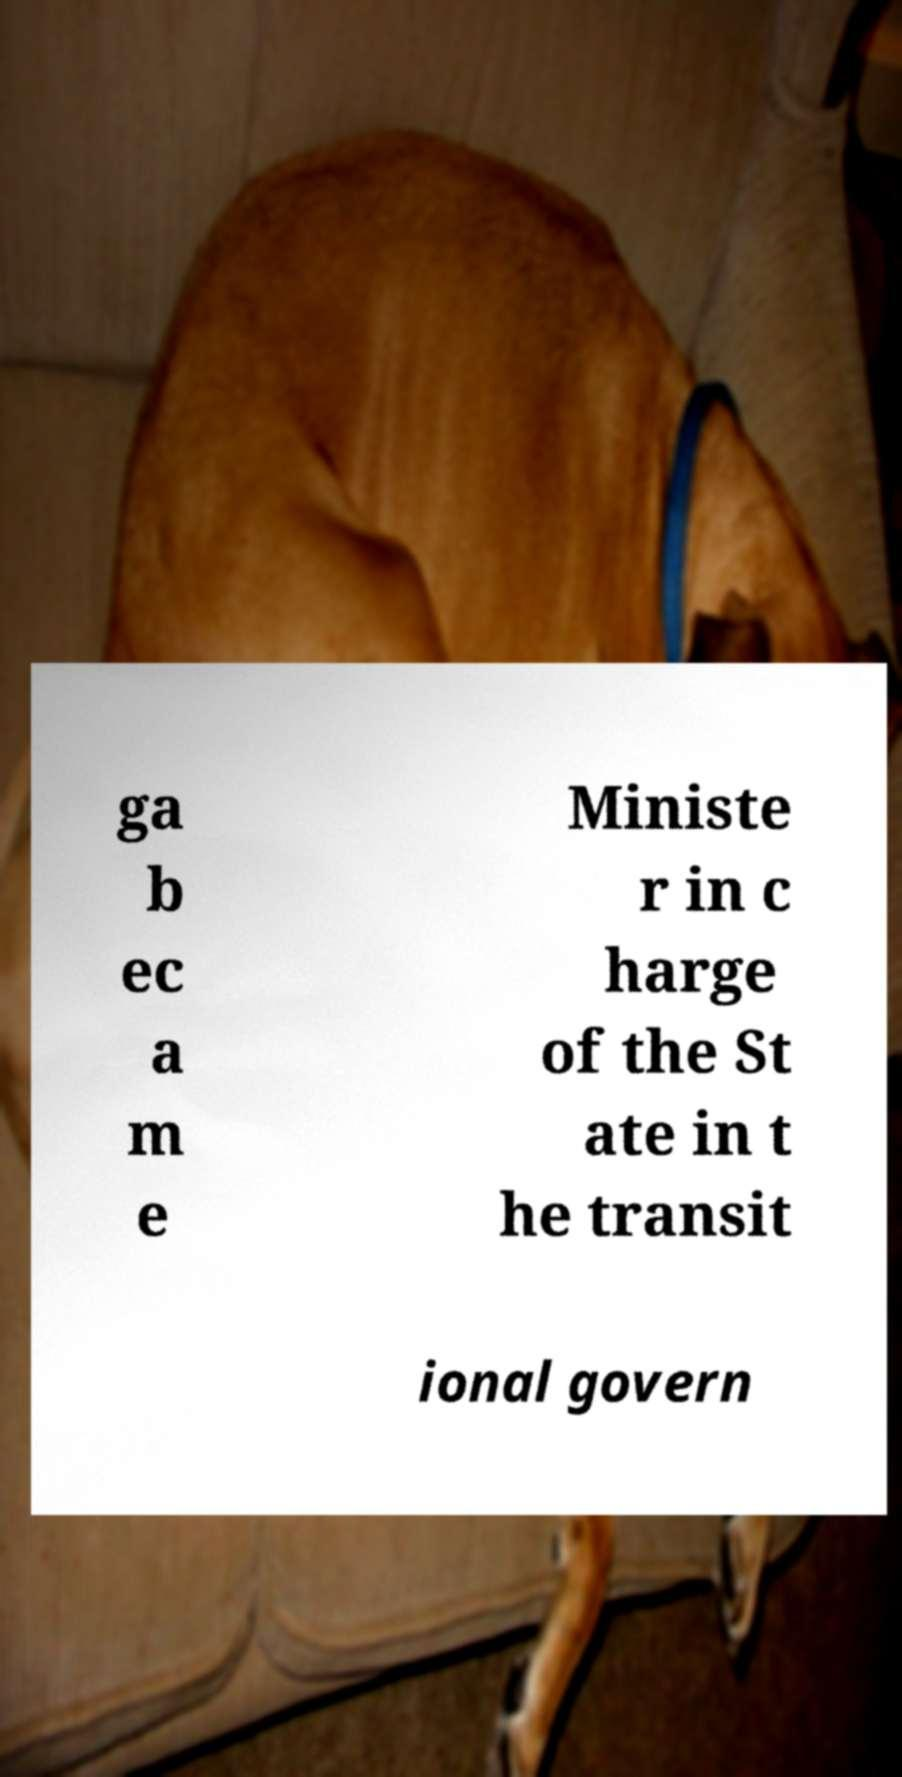For documentation purposes, I need the text within this image transcribed. Could you provide that? ga b ec a m e Ministe r in c harge of the St ate in t he transit ional govern 